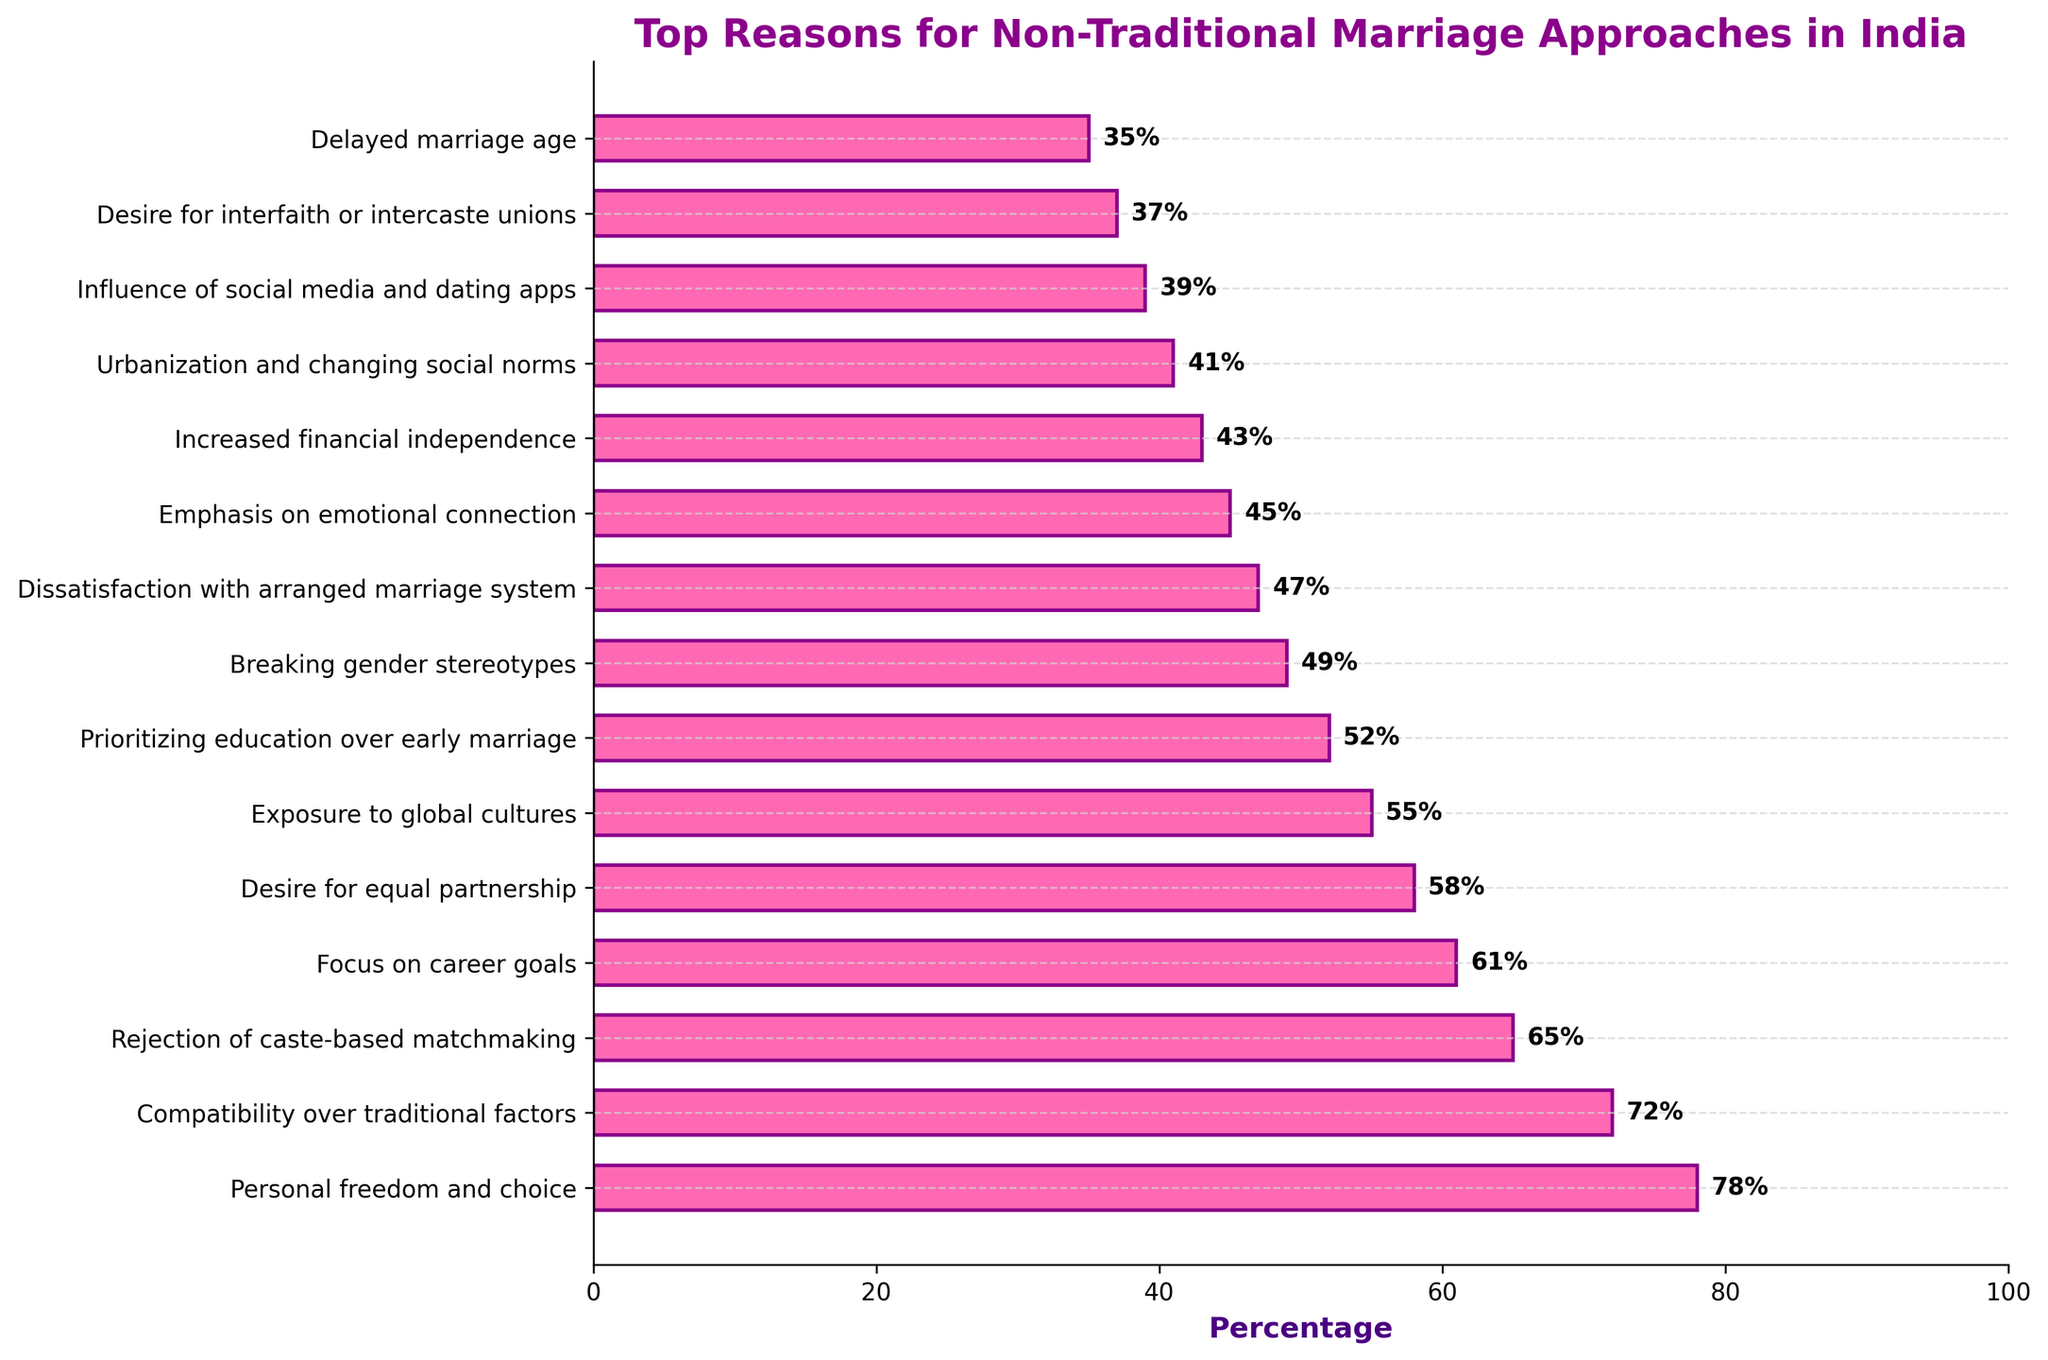What is the top reason cited by Indian couples for choosing non-traditional marriage approaches? The top reason can be identified by looking at the longest bar in the bar chart, which represents 'Personal freedom and choice' with a percentage of 78.
Answer: Personal freedom and choice Which reason has the second-highest percentage? The second-highest percentage is identified by looking at the bar that is second longest. It corresponds to 'Compatibility over traditional factors' with 72%.
Answer: Compatibility over traditional factors What is the percentage difference between 'Rejection of caste-based matchmaking' and 'Focus on career goals'? First, find the percentages of both reasons from the chart: 'Rejection of caste-based matchmaking' is 65% and 'Focus on career goals' is 61%. Subtract the smaller from the larger: 65% - 61% = 4%.
Answer: 4% Which reason is cited more frequently: 'Desire for equal partnership' or 'Exposure to global cultures'? Compare the lengths of the bars for both reasons. 'Desire for equal partnership' has 58% and 'Exposure to global cultures' has 55%, making 'Desire for equal partnership' cited more frequently.
Answer: Desire for equal partnership Identify the reasons with percentages greater than 50%. Identify bars that extend beyond the 50% mark. These reasons are 'Personal freedom and choice' (78%), 'Compatibility over traditional factors' (72%), 'Rejection of caste-based matchmaking' (65%), 'Focus on career goals' (61%), 'Desire for equal partnership' (58%), and 'Exposure to global cultures' (55%).
Answer: Personal freedom and choice, Compatibility over traditional factors, Rejection of caste-based matchmaking, Focus on career goals, Desire for equal partnership, Exposure to global cultures What is the total percentage for the top three reasons combined? Sum the percentages of the top three reasons: 'Personal freedom and choice' (78%), 'Compatibility over traditional factors' (72%), and 'Rejection of caste-based matchmaking' (65%). Add these together: 78 + 72 + 65 = 215.
Answer: 215 How does 'Urbanization and changing social norms' compare to 'Dissatisfaction with arranged marriage system'? Compare the percentage bars. 'Urbanization and changing social norms' is 41% while 'Dissatisfaction with arranged marriage system' is 47%, indicating that 'Dissatisfaction with arranged marriage system' is higher by 6%.
Answer: Dissatisfaction with arranged marriage system is higher Which reason is cited just slightly more than 'Breaking gender stereotypes'? Look at the percentage next to 'Breaking gender stereotypes', which is 49%, and then find the next higher percentage. This is 'Prioritizing education over early marriage' with 52%.
Answer: Prioritizing education over early marriage How many reasons have a percentage less than 40%? Identify bars that fall below the 40% mark. These reasons are 'Influence of social media and dating apps' (39%), 'Desire for interfaith or intercaste unions' (37%), and 'Delayed marriage age' (35%). So, there are 3 reasons.
Answer: 3 What is the combined percentage of 'Increased financial independence' and 'Urbanization and changing social norms'? Sum the percentages for the two reasons: 'Increased financial independence' (43%) and 'Urbanization and changing social norms' (41%). Add these together: 43 + 41 = 84.
Answer: 84 